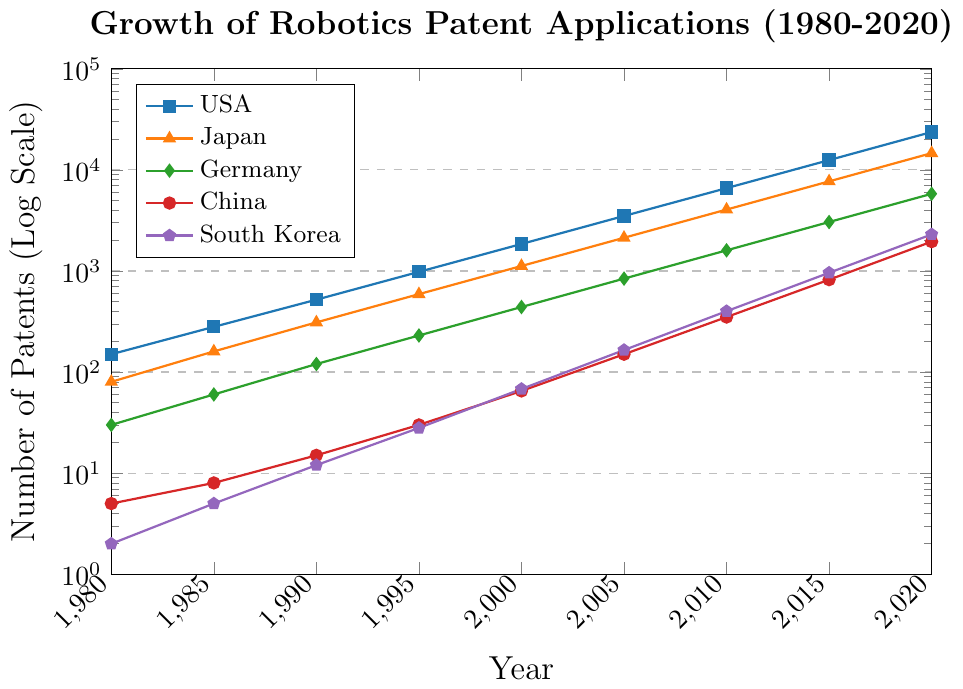What is the general trend of robotics patent applications for the USA from 1980 to 2020? The trend for the USA shows a steady increase in the number of robotics patent applications filed annually from 1980 (150) to 2020 (23700). The growth appears exponential.
Answer: Increasing trend Which country had the highest number of robotics patent applications in 2020? By examining the figure, the USA had the highest number of robotics patent applications in 2020 with 23700 applications.
Answer: USA In what year did Japan have approximately the same number of patent applications as Germany in 2020? In 2005, Japan had 2130 applications, which is close to Germany's 5800 applications in 2020 when considering the logarithmic scale used.
Answer: 2005 Between 2000 and 2020, which country's patent applications grew the fastest? Comparing the growth slopes, China's patent applications grew the fastest from 65 in 2000 to 1950 in 2020, showing a rapid increase especially in the later years.
Answer: China What is the percentage increase in patent applications for South Korea from 1980 to 2020? South Korea had 2 applications in 1980 and 2300 in 2020. The percentage increase is calculated as ((2300-2)/2) x 100 = 114900%.
Answer: 114900% How does the number of patents in Japan in 1990 compare to the number in Germany in the same year? In 1990, Japan had 310 applications, while Germany had 120 applications. Japan had more than Germany.
Answer: Japan had more What was the number of patent applications for Germany in 2015? By examining the figure, the data point for Germany in 2015 indicates 3050 applications.
Answer: 3050 Which country had the lowest number of patent applications in 1980, and how many were filed? South Korea had the lowest number of patent applications in 1980, with only 2 applications filed.
Answer: South Korea, 2 Between 2000 and 2005, which country saw the largest increase in patent applications? The USA saw the largest increase from 1850 in 2000 to 3500 in 2005, an increase of 1650 applications.
Answer: USA 